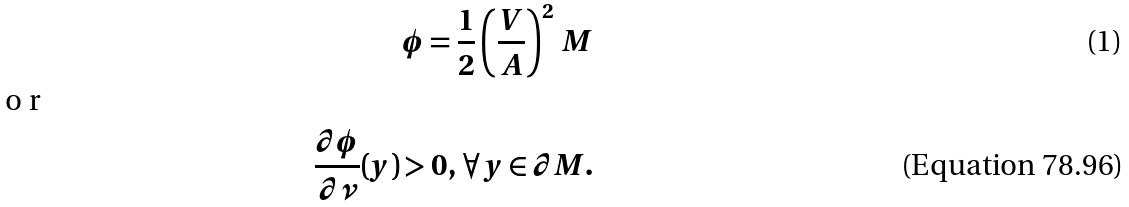<formula> <loc_0><loc_0><loc_500><loc_500>\phi = \frac { 1 } { 2 } \left ( \frac { V } { A } \right ) ^ { 2 } \, M \intertext { o r } \frac { \partial \phi } { \partial \nu } ( y ) > 0 , \, \forall \, y \in \partial M .</formula> 